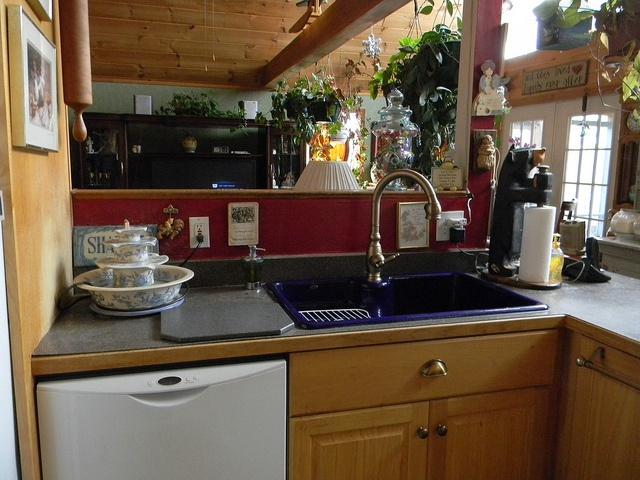Describe the objects in this image and their specific colors. I can see sink in tan, black, navy, gray, and darkgray tones, potted plant in tan, black, darkgreen, and gray tones, bowl in tan, gray, darkgray, and black tones, potted plant in tan, gray, maroon, and olive tones, and potted plant in tan, gray, darkgray, darkgreen, and olive tones in this image. 